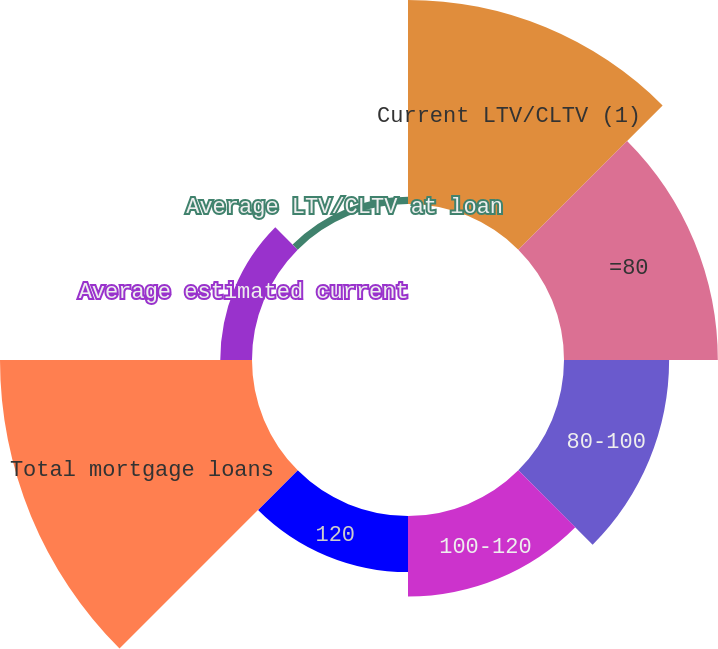Convert chart. <chart><loc_0><loc_0><loc_500><loc_500><pie_chart><fcel>Current LTV/CLTV (1)<fcel>=80<fcel>80-100<fcel>100-120<fcel>120<fcel>Total mortgage loans<fcel>Average estimated current<fcel>Average LTV/CLTV at loan<nl><fcel>22.91%<fcel>17.27%<fcel>11.8%<fcel>9.05%<fcel>6.3%<fcel>28.29%<fcel>3.56%<fcel>0.81%<nl></chart> 